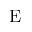Convert formula to latex. <formula><loc_0><loc_0><loc_500><loc_500>E</formula> 